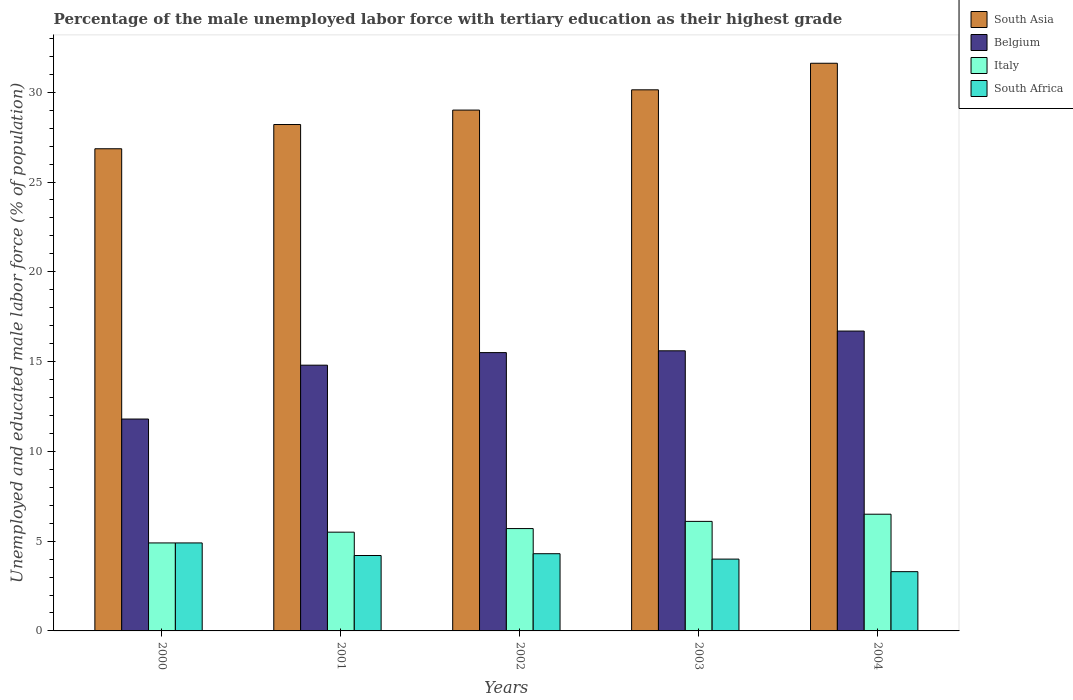How many different coloured bars are there?
Give a very brief answer. 4. Are the number of bars per tick equal to the number of legend labels?
Offer a terse response. Yes. Are the number of bars on each tick of the X-axis equal?
Give a very brief answer. Yes. What is the label of the 3rd group of bars from the left?
Ensure brevity in your answer.  2002. In how many cases, is the number of bars for a given year not equal to the number of legend labels?
Offer a very short reply. 0. What is the percentage of the unemployed male labor force with tertiary education in Italy in 2000?
Give a very brief answer. 4.9. Across all years, what is the minimum percentage of the unemployed male labor force with tertiary education in Belgium?
Keep it short and to the point. 11.8. In which year was the percentage of the unemployed male labor force with tertiary education in South Asia minimum?
Keep it short and to the point. 2000. What is the total percentage of the unemployed male labor force with tertiary education in South Africa in the graph?
Offer a very short reply. 20.7. What is the difference between the percentage of the unemployed male labor force with tertiary education in Italy in 2001 and that in 2004?
Your answer should be compact. -1. What is the difference between the percentage of the unemployed male labor force with tertiary education in South Africa in 2000 and the percentage of the unemployed male labor force with tertiary education in Italy in 2004?
Provide a succinct answer. -1.6. What is the average percentage of the unemployed male labor force with tertiary education in South Asia per year?
Your answer should be very brief. 29.16. In the year 2000, what is the difference between the percentage of the unemployed male labor force with tertiary education in Italy and percentage of the unemployed male labor force with tertiary education in Belgium?
Keep it short and to the point. -6.9. What is the ratio of the percentage of the unemployed male labor force with tertiary education in South Africa in 2001 to that in 2002?
Your answer should be very brief. 0.98. Is the percentage of the unemployed male labor force with tertiary education in South Africa in 2000 less than that in 2002?
Your answer should be very brief. No. What is the difference between the highest and the second highest percentage of the unemployed male labor force with tertiary education in Belgium?
Provide a short and direct response. 1.1. What is the difference between the highest and the lowest percentage of the unemployed male labor force with tertiary education in Italy?
Make the answer very short. 1.6. In how many years, is the percentage of the unemployed male labor force with tertiary education in South Asia greater than the average percentage of the unemployed male labor force with tertiary education in South Asia taken over all years?
Offer a very short reply. 2. Is it the case that in every year, the sum of the percentage of the unemployed male labor force with tertiary education in South Asia and percentage of the unemployed male labor force with tertiary education in Belgium is greater than the sum of percentage of the unemployed male labor force with tertiary education in South Africa and percentage of the unemployed male labor force with tertiary education in Italy?
Ensure brevity in your answer.  Yes. How many bars are there?
Make the answer very short. 20. What is the difference between two consecutive major ticks on the Y-axis?
Make the answer very short. 5. Where does the legend appear in the graph?
Your response must be concise. Top right. What is the title of the graph?
Your answer should be compact. Percentage of the male unemployed labor force with tertiary education as their highest grade. What is the label or title of the Y-axis?
Offer a terse response. Unemployed and educated male labor force (% of population). What is the Unemployed and educated male labor force (% of population) of South Asia in 2000?
Ensure brevity in your answer.  26.85. What is the Unemployed and educated male labor force (% of population) in Belgium in 2000?
Provide a short and direct response. 11.8. What is the Unemployed and educated male labor force (% of population) in Italy in 2000?
Your answer should be very brief. 4.9. What is the Unemployed and educated male labor force (% of population) in South Africa in 2000?
Your response must be concise. 4.9. What is the Unemployed and educated male labor force (% of population) of South Asia in 2001?
Offer a very short reply. 28.2. What is the Unemployed and educated male labor force (% of population) of Belgium in 2001?
Ensure brevity in your answer.  14.8. What is the Unemployed and educated male labor force (% of population) of Italy in 2001?
Offer a terse response. 5.5. What is the Unemployed and educated male labor force (% of population) of South Africa in 2001?
Provide a short and direct response. 4.2. What is the Unemployed and educated male labor force (% of population) of South Asia in 2002?
Keep it short and to the point. 29.01. What is the Unemployed and educated male labor force (% of population) of Belgium in 2002?
Provide a succinct answer. 15.5. What is the Unemployed and educated male labor force (% of population) of Italy in 2002?
Provide a succinct answer. 5.7. What is the Unemployed and educated male labor force (% of population) in South Africa in 2002?
Ensure brevity in your answer.  4.3. What is the Unemployed and educated male labor force (% of population) in South Asia in 2003?
Make the answer very short. 30.14. What is the Unemployed and educated male labor force (% of population) of Belgium in 2003?
Your response must be concise. 15.6. What is the Unemployed and educated male labor force (% of population) of Italy in 2003?
Your answer should be compact. 6.1. What is the Unemployed and educated male labor force (% of population) in South Asia in 2004?
Your answer should be very brief. 31.61. What is the Unemployed and educated male labor force (% of population) in Belgium in 2004?
Provide a short and direct response. 16.7. What is the Unemployed and educated male labor force (% of population) in South Africa in 2004?
Provide a succinct answer. 3.3. Across all years, what is the maximum Unemployed and educated male labor force (% of population) in South Asia?
Your answer should be very brief. 31.61. Across all years, what is the maximum Unemployed and educated male labor force (% of population) in Belgium?
Give a very brief answer. 16.7. Across all years, what is the maximum Unemployed and educated male labor force (% of population) in South Africa?
Ensure brevity in your answer.  4.9. Across all years, what is the minimum Unemployed and educated male labor force (% of population) in South Asia?
Your answer should be compact. 26.85. Across all years, what is the minimum Unemployed and educated male labor force (% of population) of Belgium?
Your response must be concise. 11.8. Across all years, what is the minimum Unemployed and educated male labor force (% of population) in Italy?
Offer a very short reply. 4.9. Across all years, what is the minimum Unemployed and educated male labor force (% of population) in South Africa?
Ensure brevity in your answer.  3.3. What is the total Unemployed and educated male labor force (% of population) of South Asia in the graph?
Provide a succinct answer. 145.81. What is the total Unemployed and educated male labor force (% of population) of Belgium in the graph?
Your response must be concise. 74.4. What is the total Unemployed and educated male labor force (% of population) in Italy in the graph?
Provide a short and direct response. 28.7. What is the total Unemployed and educated male labor force (% of population) in South Africa in the graph?
Keep it short and to the point. 20.7. What is the difference between the Unemployed and educated male labor force (% of population) in South Asia in 2000 and that in 2001?
Provide a succinct answer. -1.35. What is the difference between the Unemployed and educated male labor force (% of population) in Belgium in 2000 and that in 2001?
Make the answer very short. -3. What is the difference between the Unemployed and educated male labor force (% of population) in South Africa in 2000 and that in 2001?
Keep it short and to the point. 0.7. What is the difference between the Unemployed and educated male labor force (% of population) in South Asia in 2000 and that in 2002?
Give a very brief answer. -2.15. What is the difference between the Unemployed and educated male labor force (% of population) of Belgium in 2000 and that in 2002?
Provide a short and direct response. -3.7. What is the difference between the Unemployed and educated male labor force (% of population) of South Asia in 2000 and that in 2003?
Your answer should be compact. -3.28. What is the difference between the Unemployed and educated male labor force (% of population) of South Asia in 2000 and that in 2004?
Your answer should be very brief. -4.76. What is the difference between the Unemployed and educated male labor force (% of population) in South Asia in 2001 and that in 2002?
Offer a terse response. -0.8. What is the difference between the Unemployed and educated male labor force (% of population) of Italy in 2001 and that in 2002?
Provide a succinct answer. -0.2. What is the difference between the Unemployed and educated male labor force (% of population) in South Africa in 2001 and that in 2002?
Ensure brevity in your answer.  -0.1. What is the difference between the Unemployed and educated male labor force (% of population) in South Asia in 2001 and that in 2003?
Make the answer very short. -1.93. What is the difference between the Unemployed and educated male labor force (% of population) in Italy in 2001 and that in 2003?
Your answer should be compact. -0.6. What is the difference between the Unemployed and educated male labor force (% of population) of South Asia in 2001 and that in 2004?
Your response must be concise. -3.41. What is the difference between the Unemployed and educated male labor force (% of population) in Belgium in 2001 and that in 2004?
Offer a terse response. -1.9. What is the difference between the Unemployed and educated male labor force (% of population) of South Africa in 2001 and that in 2004?
Make the answer very short. 0.9. What is the difference between the Unemployed and educated male labor force (% of population) of South Asia in 2002 and that in 2003?
Offer a terse response. -1.13. What is the difference between the Unemployed and educated male labor force (% of population) of South Asia in 2002 and that in 2004?
Ensure brevity in your answer.  -2.61. What is the difference between the Unemployed and educated male labor force (% of population) in Belgium in 2002 and that in 2004?
Provide a succinct answer. -1.2. What is the difference between the Unemployed and educated male labor force (% of population) of Italy in 2002 and that in 2004?
Your response must be concise. -0.8. What is the difference between the Unemployed and educated male labor force (% of population) in South Asia in 2003 and that in 2004?
Your answer should be compact. -1.48. What is the difference between the Unemployed and educated male labor force (% of population) of Italy in 2003 and that in 2004?
Give a very brief answer. -0.4. What is the difference between the Unemployed and educated male labor force (% of population) of South Africa in 2003 and that in 2004?
Offer a very short reply. 0.7. What is the difference between the Unemployed and educated male labor force (% of population) in South Asia in 2000 and the Unemployed and educated male labor force (% of population) in Belgium in 2001?
Keep it short and to the point. 12.05. What is the difference between the Unemployed and educated male labor force (% of population) of South Asia in 2000 and the Unemployed and educated male labor force (% of population) of Italy in 2001?
Ensure brevity in your answer.  21.35. What is the difference between the Unemployed and educated male labor force (% of population) in South Asia in 2000 and the Unemployed and educated male labor force (% of population) in South Africa in 2001?
Provide a succinct answer. 22.65. What is the difference between the Unemployed and educated male labor force (% of population) in Belgium in 2000 and the Unemployed and educated male labor force (% of population) in Italy in 2001?
Your answer should be very brief. 6.3. What is the difference between the Unemployed and educated male labor force (% of population) of Belgium in 2000 and the Unemployed and educated male labor force (% of population) of South Africa in 2001?
Offer a terse response. 7.6. What is the difference between the Unemployed and educated male labor force (% of population) of Italy in 2000 and the Unemployed and educated male labor force (% of population) of South Africa in 2001?
Offer a terse response. 0.7. What is the difference between the Unemployed and educated male labor force (% of population) of South Asia in 2000 and the Unemployed and educated male labor force (% of population) of Belgium in 2002?
Offer a terse response. 11.35. What is the difference between the Unemployed and educated male labor force (% of population) in South Asia in 2000 and the Unemployed and educated male labor force (% of population) in Italy in 2002?
Your response must be concise. 21.15. What is the difference between the Unemployed and educated male labor force (% of population) in South Asia in 2000 and the Unemployed and educated male labor force (% of population) in South Africa in 2002?
Give a very brief answer. 22.55. What is the difference between the Unemployed and educated male labor force (% of population) in Belgium in 2000 and the Unemployed and educated male labor force (% of population) in Italy in 2002?
Ensure brevity in your answer.  6.1. What is the difference between the Unemployed and educated male labor force (% of population) of Belgium in 2000 and the Unemployed and educated male labor force (% of population) of South Africa in 2002?
Offer a terse response. 7.5. What is the difference between the Unemployed and educated male labor force (% of population) in South Asia in 2000 and the Unemployed and educated male labor force (% of population) in Belgium in 2003?
Offer a terse response. 11.25. What is the difference between the Unemployed and educated male labor force (% of population) of South Asia in 2000 and the Unemployed and educated male labor force (% of population) of Italy in 2003?
Your response must be concise. 20.75. What is the difference between the Unemployed and educated male labor force (% of population) in South Asia in 2000 and the Unemployed and educated male labor force (% of population) in South Africa in 2003?
Your answer should be compact. 22.85. What is the difference between the Unemployed and educated male labor force (% of population) in Belgium in 2000 and the Unemployed and educated male labor force (% of population) in Italy in 2003?
Ensure brevity in your answer.  5.7. What is the difference between the Unemployed and educated male labor force (% of population) in South Asia in 2000 and the Unemployed and educated male labor force (% of population) in Belgium in 2004?
Provide a short and direct response. 10.15. What is the difference between the Unemployed and educated male labor force (% of population) of South Asia in 2000 and the Unemployed and educated male labor force (% of population) of Italy in 2004?
Your answer should be compact. 20.35. What is the difference between the Unemployed and educated male labor force (% of population) in South Asia in 2000 and the Unemployed and educated male labor force (% of population) in South Africa in 2004?
Your response must be concise. 23.55. What is the difference between the Unemployed and educated male labor force (% of population) of South Asia in 2001 and the Unemployed and educated male labor force (% of population) of Belgium in 2002?
Your answer should be very brief. 12.7. What is the difference between the Unemployed and educated male labor force (% of population) in South Asia in 2001 and the Unemployed and educated male labor force (% of population) in Italy in 2002?
Provide a short and direct response. 22.5. What is the difference between the Unemployed and educated male labor force (% of population) of South Asia in 2001 and the Unemployed and educated male labor force (% of population) of South Africa in 2002?
Your answer should be compact. 23.9. What is the difference between the Unemployed and educated male labor force (% of population) in Belgium in 2001 and the Unemployed and educated male labor force (% of population) in Italy in 2002?
Offer a terse response. 9.1. What is the difference between the Unemployed and educated male labor force (% of population) of South Asia in 2001 and the Unemployed and educated male labor force (% of population) of Belgium in 2003?
Provide a short and direct response. 12.6. What is the difference between the Unemployed and educated male labor force (% of population) of South Asia in 2001 and the Unemployed and educated male labor force (% of population) of Italy in 2003?
Offer a very short reply. 22.1. What is the difference between the Unemployed and educated male labor force (% of population) of South Asia in 2001 and the Unemployed and educated male labor force (% of population) of South Africa in 2003?
Your answer should be compact. 24.2. What is the difference between the Unemployed and educated male labor force (% of population) in Belgium in 2001 and the Unemployed and educated male labor force (% of population) in South Africa in 2003?
Provide a succinct answer. 10.8. What is the difference between the Unemployed and educated male labor force (% of population) in South Asia in 2001 and the Unemployed and educated male labor force (% of population) in Belgium in 2004?
Offer a very short reply. 11.5. What is the difference between the Unemployed and educated male labor force (% of population) in South Asia in 2001 and the Unemployed and educated male labor force (% of population) in Italy in 2004?
Your answer should be very brief. 21.7. What is the difference between the Unemployed and educated male labor force (% of population) in South Asia in 2001 and the Unemployed and educated male labor force (% of population) in South Africa in 2004?
Keep it short and to the point. 24.9. What is the difference between the Unemployed and educated male labor force (% of population) in Belgium in 2001 and the Unemployed and educated male labor force (% of population) in South Africa in 2004?
Your response must be concise. 11.5. What is the difference between the Unemployed and educated male labor force (% of population) of Italy in 2001 and the Unemployed and educated male labor force (% of population) of South Africa in 2004?
Give a very brief answer. 2.2. What is the difference between the Unemployed and educated male labor force (% of population) of South Asia in 2002 and the Unemployed and educated male labor force (% of population) of Belgium in 2003?
Provide a short and direct response. 13.41. What is the difference between the Unemployed and educated male labor force (% of population) of South Asia in 2002 and the Unemployed and educated male labor force (% of population) of Italy in 2003?
Provide a succinct answer. 22.91. What is the difference between the Unemployed and educated male labor force (% of population) in South Asia in 2002 and the Unemployed and educated male labor force (% of population) in South Africa in 2003?
Provide a short and direct response. 25.01. What is the difference between the Unemployed and educated male labor force (% of population) of Belgium in 2002 and the Unemployed and educated male labor force (% of population) of Italy in 2003?
Your answer should be compact. 9.4. What is the difference between the Unemployed and educated male labor force (% of population) in Belgium in 2002 and the Unemployed and educated male labor force (% of population) in South Africa in 2003?
Keep it short and to the point. 11.5. What is the difference between the Unemployed and educated male labor force (% of population) of South Asia in 2002 and the Unemployed and educated male labor force (% of population) of Belgium in 2004?
Your answer should be compact. 12.31. What is the difference between the Unemployed and educated male labor force (% of population) of South Asia in 2002 and the Unemployed and educated male labor force (% of population) of Italy in 2004?
Offer a terse response. 22.51. What is the difference between the Unemployed and educated male labor force (% of population) of South Asia in 2002 and the Unemployed and educated male labor force (% of population) of South Africa in 2004?
Ensure brevity in your answer.  25.71. What is the difference between the Unemployed and educated male labor force (% of population) in Belgium in 2002 and the Unemployed and educated male labor force (% of population) in Italy in 2004?
Your response must be concise. 9. What is the difference between the Unemployed and educated male labor force (% of population) of Belgium in 2002 and the Unemployed and educated male labor force (% of population) of South Africa in 2004?
Give a very brief answer. 12.2. What is the difference between the Unemployed and educated male labor force (% of population) of Italy in 2002 and the Unemployed and educated male labor force (% of population) of South Africa in 2004?
Offer a terse response. 2.4. What is the difference between the Unemployed and educated male labor force (% of population) in South Asia in 2003 and the Unemployed and educated male labor force (% of population) in Belgium in 2004?
Give a very brief answer. 13.44. What is the difference between the Unemployed and educated male labor force (% of population) of South Asia in 2003 and the Unemployed and educated male labor force (% of population) of Italy in 2004?
Give a very brief answer. 23.64. What is the difference between the Unemployed and educated male labor force (% of population) of South Asia in 2003 and the Unemployed and educated male labor force (% of population) of South Africa in 2004?
Provide a short and direct response. 26.84. What is the difference between the Unemployed and educated male labor force (% of population) in Belgium in 2003 and the Unemployed and educated male labor force (% of population) in Italy in 2004?
Your response must be concise. 9.1. What is the difference between the Unemployed and educated male labor force (% of population) of Italy in 2003 and the Unemployed and educated male labor force (% of population) of South Africa in 2004?
Offer a very short reply. 2.8. What is the average Unemployed and educated male labor force (% of population) of South Asia per year?
Your answer should be compact. 29.16. What is the average Unemployed and educated male labor force (% of population) of Belgium per year?
Make the answer very short. 14.88. What is the average Unemployed and educated male labor force (% of population) in Italy per year?
Ensure brevity in your answer.  5.74. What is the average Unemployed and educated male labor force (% of population) in South Africa per year?
Offer a terse response. 4.14. In the year 2000, what is the difference between the Unemployed and educated male labor force (% of population) of South Asia and Unemployed and educated male labor force (% of population) of Belgium?
Provide a succinct answer. 15.05. In the year 2000, what is the difference between the Unemployed and educated male labor force (% of population) of South Asia and Unemployed and educated male labor force (% of population) of Italy?
Make the answer very short. 21.95. In the year 2000, what is the difference between the Unemployed and educated male labor force (% of population) of South Asia and Unemployed and educated male labor force (% of population) of South Africa?
Offer a terse response. 21.95. In the year 2000, what is the difference between the Unemployed and educated male labor force (% of population) in Belgium and Unemployed and educated male labor force (% of population) in Italy?
Your answer should be compact. 6.9. In the year 2000, what is the difference between the Unemployed and educated male labor force (% of population) in Belgium and Unemployed and educated male labor force (% of population) in South Africa?
Offer a very short reply. 6.9. In the year 2001, what is the difference between the Unemployed and educated male labor force (% of population) in South Asia and Unemployed and educated male labor force (% of population) in Belgium?
Your response must be concise. 13.4. In the year 2001, what is the difference between the Unemployed and educated male labor force (% of population) in South Asia and Unemployed and educated male labor force (% of population) in Italy?
Keep it short and to the point. 22.7. In the year 2001, what is the difference between the Unemployed and educated male labor force (% of population) of South Asia and Unemployed and educated male labor force (% of population) of South Africa?
Provide a short and direct response. 24. In the year 2001, what is the difference between the Unemployed and educated male labor force (% of population) of Belgium and Unemployed and educated male labor force (% of population) of Italy?
Your answer should be compact. 9.3. In the year 2002, what is the difference between the Unemployed and educated male labor force (% of population) of South Asia and Unemployed and educated male labor force (% of population) of Belgium?
Make the answer very short. 13.51. In the year 2002, what is the difference between the Unemployed and educated male labor force (% of population) in South Asia and Unemployed and educated male labor force (% of population) in Italy?
Give a very brief answer. 23.31. In the year 2002, what is the difference between the Unemployed and educated male labor force (% of population) of South Asia and Unemployed and educated male labor force (% of population) of South Africa?
Ensure brevity in your answer.  24.71. In the year 2002, what is the difference between the Unemployed and educated male labor force (% of population) of Italy and Unemployed and educated male labor force (% of population) of South Africa?
Your answer should be compact. 1.4. In the year 2003, what is the difference between the Unemployed and educated male labor force (% of population) of South Asia and Unemployed and educated male labor force (% of population) of Belgium?
Make the answer very short. 14.54. In the year 2003, what is the difference between the Unemployed and educated male labor force (% of population) of South Asia and Unemployed and educated male labor force (% of population) of Italy?
Your response must be concise. 24.04. In the year 2003, what is the difference between the Unemployed and educated male labor force (% of population) in South Asia and Unemployed and educated male labor force (% of population) in South Africa?
Make the answer very short. 26.14. In the year 2003, what is the difference between the Unemployed and educated male labor force (% of population) in Belgium and Unemployed and educated male labor force (% of population) in Italy?
Your answer should be compact. 9.5. In the year 2003, what is the difference between the Unemployed and educated male labor force (% of population) of Belgium and Unemployed and educated male labor force (% of population) of South Africa?
Provide a short and direct response. 11.6. In the year 2004, what is the difference between the Unemployed and educated male labor force (% of population) of South Asia and Unemployed and educated male labor force (% of population) of Belgium?
Keep it short and to the point. 14.91. In the year 2004, what is the difference between the Unemployed and educated male labor force (% of population) in South Asia and Unemployed and educated male labor force (% of population) in Italy?
Keep it short and to the point. 25.11. In the year 2004, what is the difference between the Unemployed and educated male labor force (% of population) of South Asia and Unemployed and educated male labor force (% of population) of South Africa?
Provide a short and direct response. 28.31. What is the ratio of the Unemployed and educated male labor force (% of population) in South Asia in 2000 to that in 2001?
Provide a succinct answer. 0.95. What is the ratio of the Unemployed and educated male labor force (% of population) in Belgium in 2000 to that in 2001?
Provide a succinct answer. 0.8. What is the ratio of the Unemployed and educated male labor force (% of population) of Italy in 2000 to that in 2001?
Give a very brief answer. 0.89. What is the ratio of the Unemployed and educated male labor force (% of population) in South Africa in 2000 to that in 2001?
Ensure brevity in your answer.  1.17. What is the ratio of the Unemployed and educated male labor force (% of population) of South Asia in 2000 to that in 2002?
Your answer should be compact. 0.93. What is the ratio of the Unemployed and educated male labor force (% of population) of Belgium in 2000 to that in 2002?
Your answer should be compact. 0.76. What is the ratio of the Unemployed and educated male labor force (% of population) of Italy in 2000 to that in 2002?
Provide a short and direct response. 0.86. What is the ratio of the Unemployed and educated male labor force (% of population) in South Africa in 2000 to that in 2002?
Make the answer very short. 1.14. What is the ratio of the Unemployed and educated male labor force (% of population) of South Asia in 2000 to that in 2003?
Offer a very short reply. 0.89. What is the ratio of the Unemployed and educated male labor force (% of population) in Belgium in 2000 to that in 2003?
Make the answer very short. 0.76. What is the ratio of the Unemployed and educated male labor force (% of population) of Italy in 2000 to that in 2003?
Your answer should be very brief. 0.8. What is the ratio of the Unemployed and educated male labor force (% of population) of South Africa in 2000 to that in 2003?
Offer a terse response. 1.23. What is the ratio of the Unemployed and educated male labor force (% of population) in South Asia in 2000 to that in 2004?
Offer a terse response. 0.85. What is the ratio of the Unemployed and educated male labor force (% of population) of Belgium in 2000 to that in 2004?
Your response must be concise. 0.71. What is the ratio of the Unemployed and educated male labor force (% of population) of Italy in 2000 to that in 2004?
Your response must be concise. 0.75. What is the ratio of the Unemployed and educated male labor force (% of population) of South Africa in 2000 to that in 2004?
Ensure brevity in your answer.  1.48. What is the ratio of the Unemployed and educated male labor force (% of population) of South Asia in 2001 to that in 2002?
Your answer should be compact. 0.97. What is the ratio of the Unemployed and educated male labor force (% of population) of Belgium in 2001 to that in 2002?
Your answer should be very brief. 0.95. What is the ratio of the Unemployed and educated male labor force (% of population) in Italy in 2001 to that in 2002?
Give a very brief answer. 0.96. What is the ratio of the Unemployed and educated male labor force (% of population) of South Africa in 2001 to that in 2002?
Ensure brevity in your answer.  0.98. What is the ratio of the Unemployed and educated male labor force (% of population) of South Asia in 2001 to that in 2003?
Offer a very short reply. 0.94. What is the ratio of the Unemployed and educated male labor force (% of population) in Belgium in 2001 to that in 2003?
Provide a succinct answer. 0.95. What is the ratio of the Unemployed and educated male labor force (% of population) of Italy in 2001 to that in 2003?
Your answer should be compact. 0.9. What is the ratio of the Unemployed and educated male labor force (% of population) in South Africa in 2001 to that in 2003?
Provide a succinct answer. 1.05. What is the ratio of the Unemployed and educated male labor force (% of population) of South Asia in 2001 to that in 2004?
Your answer should be compact. 0.89. What is the ratio of the Unemployed and educated male labor force (% of population) of Belgium in 2001 to that in 2004?
Offer a very short reply. 0.89. What is the ratio of the Unemployed and educated male labor force (% of population) in Italy in 2001 to that in 2004?
Ensure brevity in your answer.  0.85. What is the ratio of the Unemployed and educated male labor force (% of population) of South Africa in 2001 to that in 2004?
Make the answer very short. 1.27. What is the ratio of the Unemployed and educated male labor force (% of population) in South Asia in 2002 to that in 2003?
Provide a short and direct response. 0.96. What is the ratio of the Unemployed and educated male labor force (% of population) of Italy in 2002 to that in 2003?
Your response must be concise. 0.93. What is the ratio of the Unemployed and educated male labor force (% of population) of South Africa in 2002 to that in 2003?
Your answer should be very brief. 1.07. What is the ratio of the Unemployed and educated male labor force (% of population) of South Asia in 2002 to that in 2004?
Make the answer very short. 0.92. What is the ratio of the Unemployed and educated male labor force (% of population) of Belgium in 2002 to that in 2004?
Provide a succinct answer. 0.93. What is the ratio of the Unemployed and educated male labor force (% of population) of Italy in 2002 to that in 2004?
Give a very brief answer. 0.88. What is the ratio of the Unemployed and educated male labor force (% of population) in South Africa in 2002 to that in 2004?
Your answer should be very brief. 1.3. What is the ratio of the Unemployed and educated male labor force (% of population) of South Asia in 2003 to that in 2004?
Offer a terse response. 0.95. What is the ratio of the Unemployed and educated male labor force (% of population) in Belgium in 2003 to that in 2004?
Make the answer very short. 0.93. What is the ratio of the Unemployed and educated male labor force (% of population) in Italy in 2003 to that in 2004?
Keep it short and to the point. 0.94. What is the ratio of the Unemployed and educated male labor force (% of population) of South Africa in 2003 to that in 2004?
Keep it short and to the point. 1.21. What is the difference between the highest and the second highest Unemployed and educated male labor force (% of population) of South Asia?
Your answer should be very brief. 1.48. What is the difference between the highest and the second highest Unemployed and educated male labor force (% of population) of Belgium?
Provide a short and direct response. 1.1. What is the difference between the highest and the second highest Unemployed and educated male labor force (% of population) of Italy?
Your answer should be very brief. 0.4. What is the difference between the highest and the lowest Unemployed and educated male labor force (% of population) in South Asia?
Your response must be concise. 4.76. What is the difference between the highest and the lowest Unemployed and educated male labor force (% of population) of Belgium?
Make the answer very short. 4.9. 